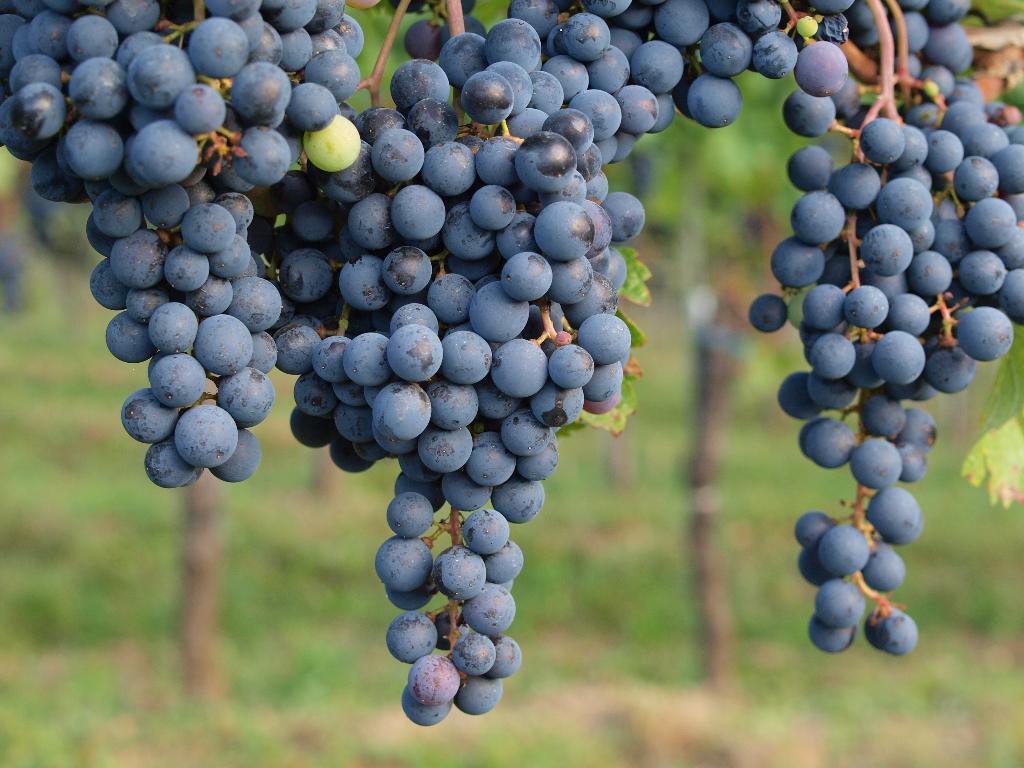How would you summarize this image in a sentence or two? In this image there are grapes in the middle. In the background there are plants. There are so many black color grapes to the plants. 